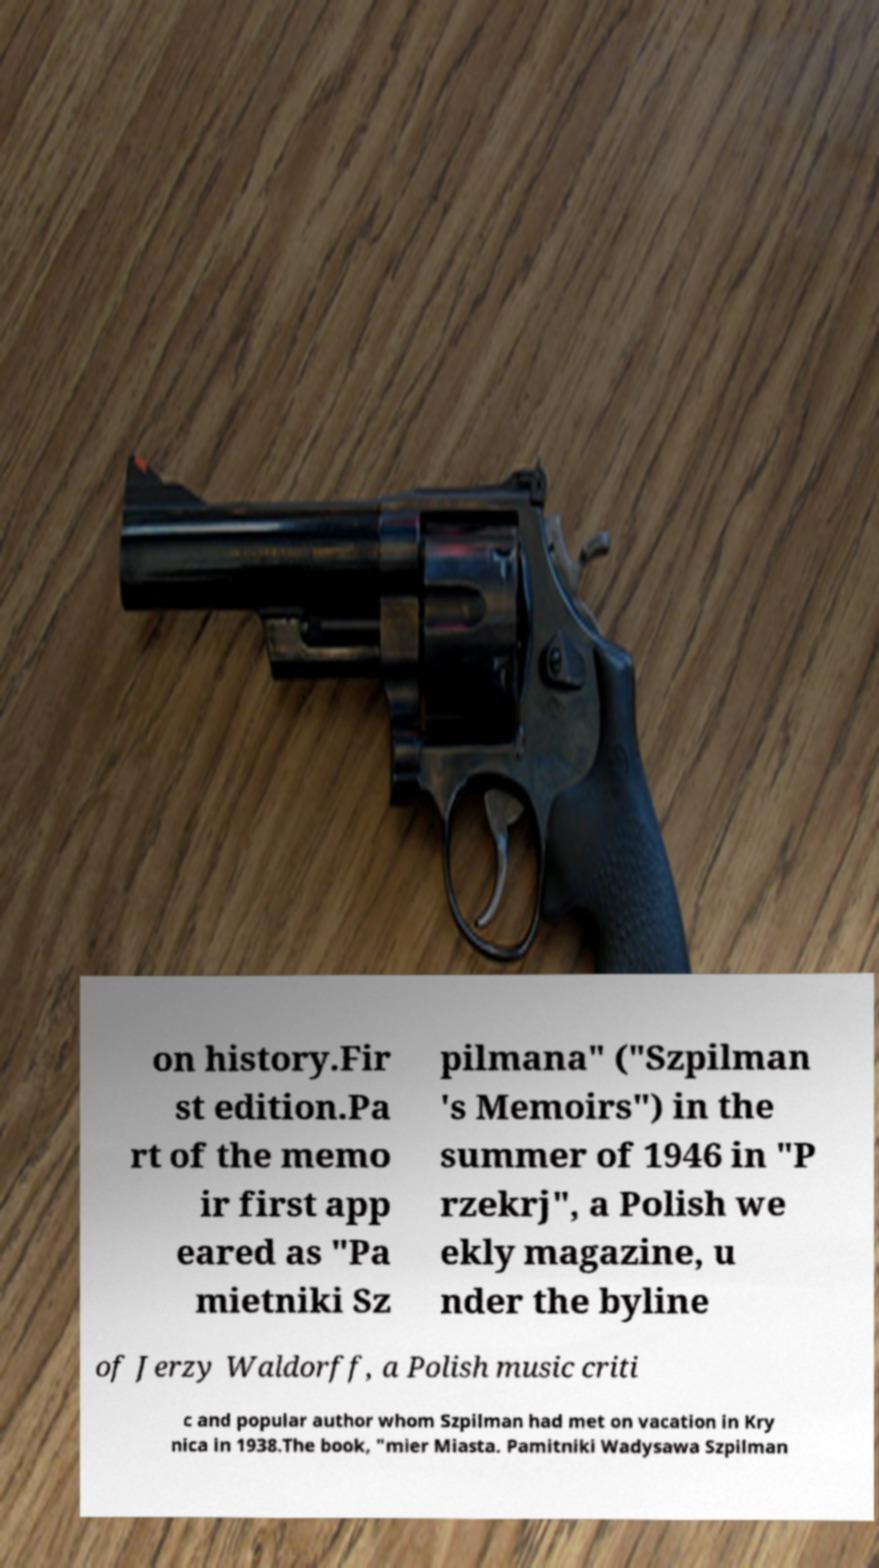I need the written content from this picture converted into text. Can you do that? on history.Fir st edition.Pa rt of the memo ir first app eared as "Pa mietniki Sz pilmana" ("Szpilman 's Memoirs") in the summer of 1946 in "P rzekrj", a Polish we ekly magazine, u nder the byline of Jerzy Waldorff, a Polish music criti c and popular author whom Szpilman had met on vacation in Kry nica in 1938.The book, "mier Miasta. Pamitniki Wadysawa Szpilman 